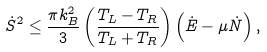<formula> <loc_0><loc_0><loc_500><loc_500>\dot { S } ^ { 2 } \leq \frac { \pi k _ { B } ^ { 2 } } { 3 } \left ( \frac { T _ { L } - T _ { R } } { T _ { L } + T _ { R } } \right ) \left ( \dot { E } - \mu \dot { N } \right ) ,</formula> 